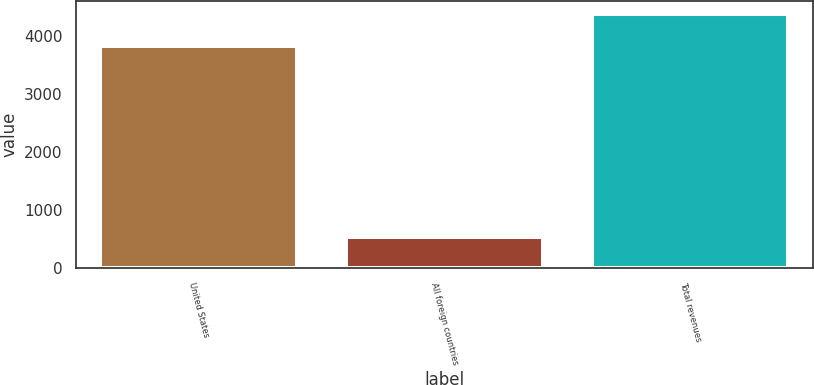Convert chart to OTSL. <chart><loc_0><loc_0><loc_500><loc_500><bar_chart><fcel>United States<fcel>All foreign countries<fcel>Total revenues<nl><fcel>3842.9<fcel>547.6<fcel>4390.5<nl></chart> 